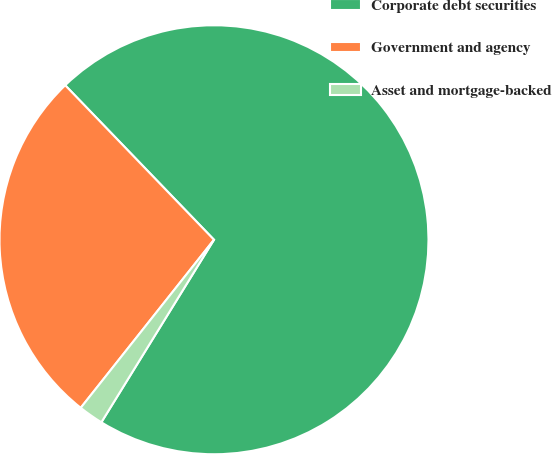Convert chart. <chart><loc_0><loc_0><loc_500><loc_500><pie_chart><fcel>Corporate debt securities<fcel>Government and agency<fcel>Asset and mortgage-backed<nl><fcel>71.0%<fcel>27.13%<fcel>1.87%<nl></chart> 